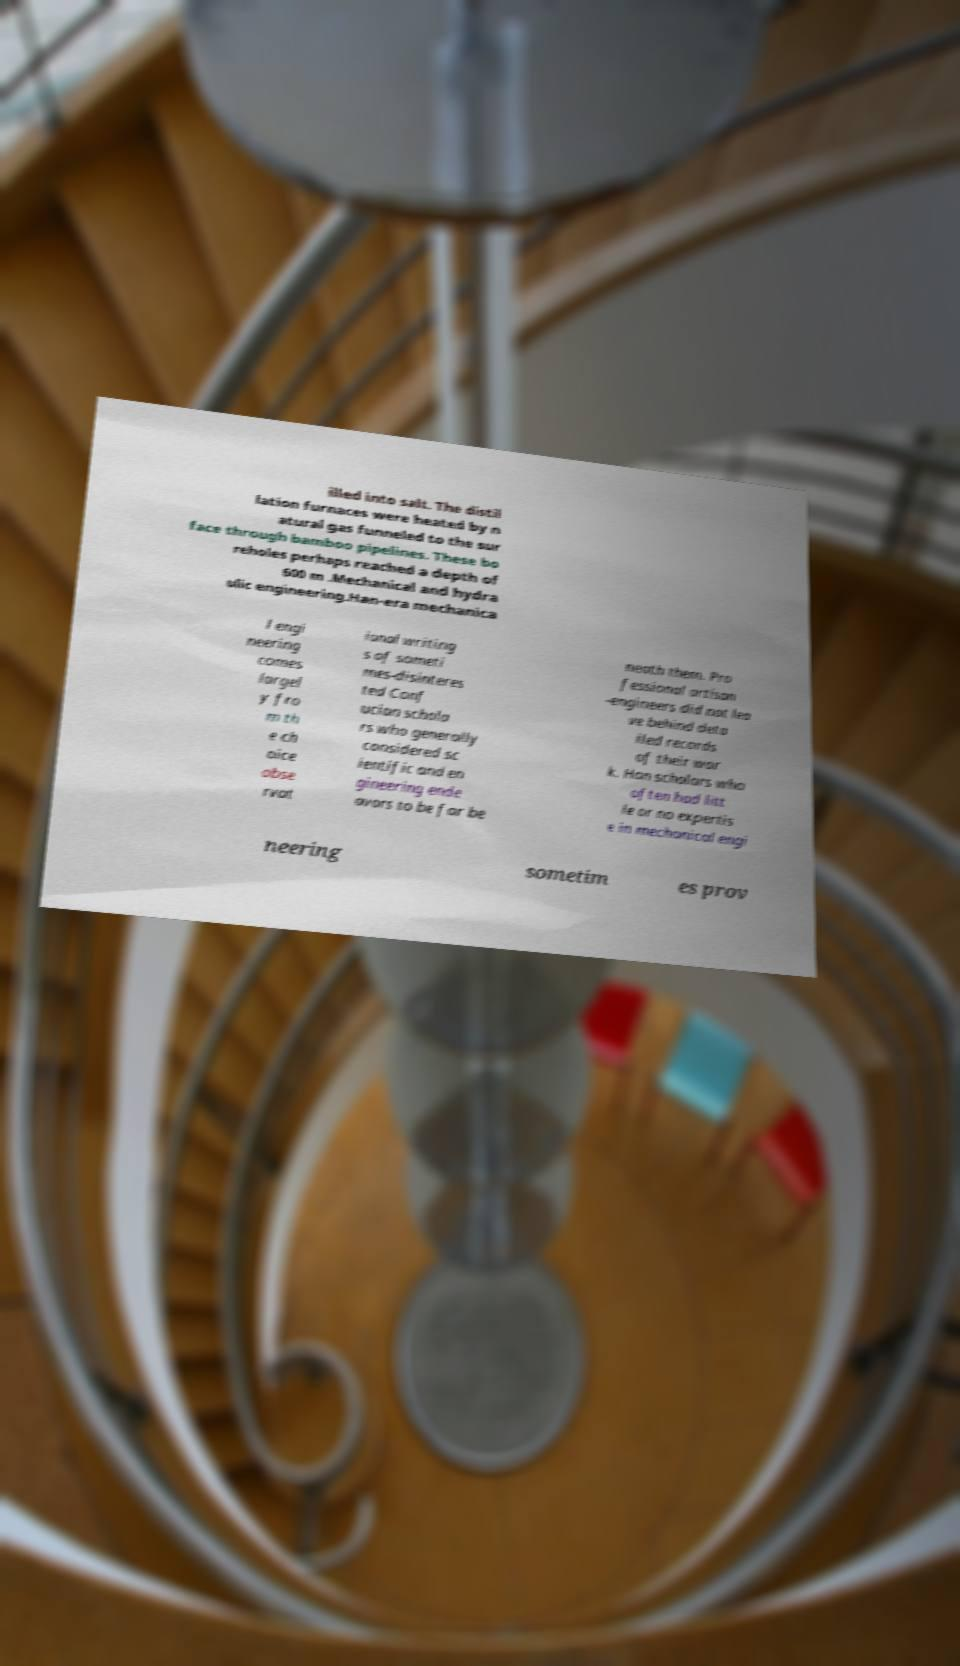Can you accurately transcribe the text from the provided image for me? illed into salt. The distil lation furnaces were heated by n atural gas funneled to the sur face through bamboo pipelines. These bo reholes perhaps reached a depth of 600 m .Mechanical and hydra ulic engineering.Han-era mechanica l engi neering comes largel y fro m th e ch oice obse rvat ional writing s of someti mes-disinteres ted Conf ucian schola rs who generally considered sc ientific and en gineering ende avors to be far be neath them. Pro fessional artisan -engineers did not lea ve behind deta iled records of their wor k. Han scholars who often had litt le or no expertis e in mechanical engi neering sometim es prov 